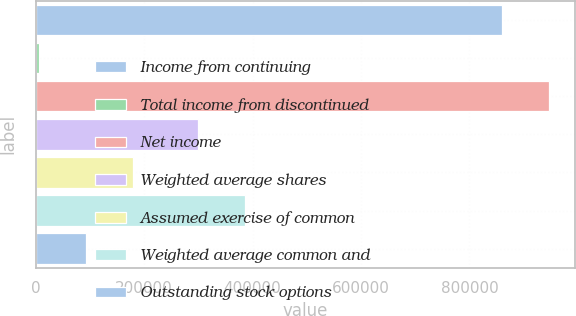<chart> <loc_0><loc_0><loc_500><loc_500><bar_chart><fcel>Income from continuing<fcel>Total income from discontinued<fcel>Net income<fcel>Weighted average shares<fcel>Assumed exercise of common<fcel>Weighted average common and<fcel>Outstanding stock options<nl><fcel>860894<fcel>6500<fcel>946983<fcel>299417<fcel>178679<fcel>385506<fcel>92589.4<nl></chart> 